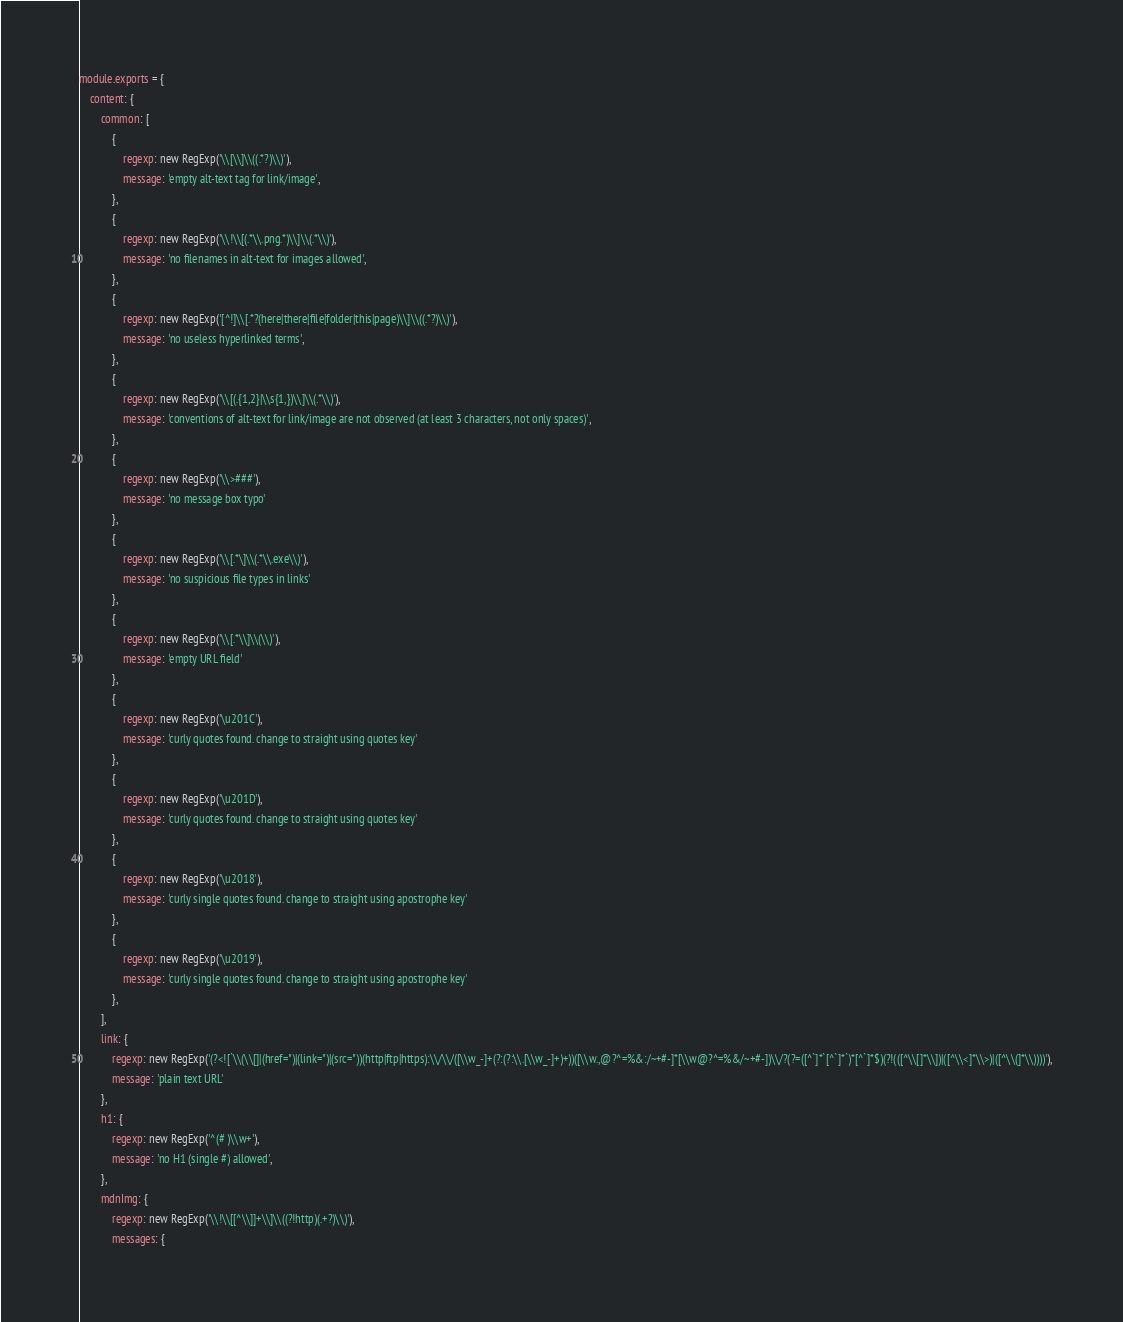<code> <loc_0><loc_0><loc_500><loc_500><_JavaScript_>module.exports = {
    content: {
        common: [
            {
                regexp: new RegExp('\\[\\]\\((.*?)\\)'),
                message: 'empty alt-text tag for link/image',
            },
            {
                regexp: new RegExp('\\!\\[(.*\\.png.*)\\]\\(.*\\)'),
                message: 'no filenames in alt-text for images allowed',
            },
            {
                regexp: new RegExp('[^!]\\[.*?(here|there|file|folder|this|page)\\]\\((.*?)\\)'),
                message: 'no useless hyperlinked terms',
            },
            {
                regexp: new RegExp('\\[(.{1,2}|\\s{1,})\\]\\(.*\\)'),
                message: 'conventions of alt-text for link/image are not observed (at least 3 characters, not only spaces)',
            },
            {
                regexp: new RegExp('\\>###'),
                message: 'no message box typo'
            },
            {
                regexp: new RegExp('\\[.*\]\\(.*\\.exe\\)'),
                message: 'no suspicious file types in links'
            },
            {
                regexp: new RegExp('\\[.*\\]\\(\\)'),
                message: 'empty URL field'
            },
            {
                regexp: new RegExp('\u201C'),
                message: 'curly quotes found. change to straight using quotes key'
            },
            {
                regexp: new RegExp('\u201D'),
                message: 'curly quotes found. change to straight using quotes key'
            },
            {
                regexp: new RegExp('\u2018'),
                message: 'curly single quotes found. change to straight using apostrophe key'
            },
            {
                regexp: new RegExp('\u2019'),
                message: 'curly single quotes found. change to straight using apostrophe key'
            },
        ],
        link: {
            regexp: new RegExp('(?<![`\\(\\[]|(href=")|(link=")|(src="))(http|ftp|https):\\/\\/([\\w_-]+(?:(?:\\.[\\w_-]+)+))([\\w.,@?^=%&:/~+#-]*[\\w@?^=%&/~+#-])\\/?(?=([^`]*`[^`]*`)*[^`]*$)(?!(([^\\[]*\\])|([^\\<]*\\>)|([^\\(]*\\))))'),
            message: 'plain text URL'
        },
        h1: {
            regexp: new RegExp('^(# )\\w+'),
            message: 'no H1 (single #) allowed',
        },
        mdnImg: {
            regexp: new RegExp('\\!\\[[^\\]]+\\]\\((?!http)(.+?)\\)'),
            messages: {</code> 